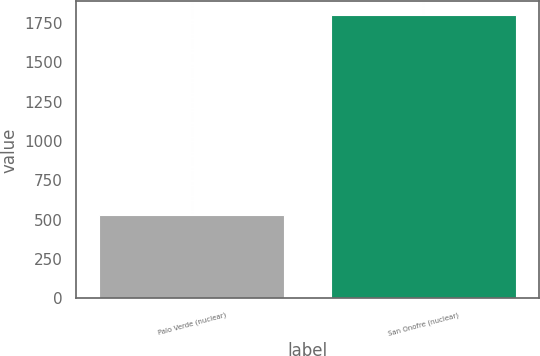Convert chart. <chart><loc_0><loc_0><loc_500><loc_500><bar_chart><fcel>Palo Verde (nuclear)<fcel>San Onofre (nuclear)<nl><fcel>530<fcel>1799<nl></chart> 